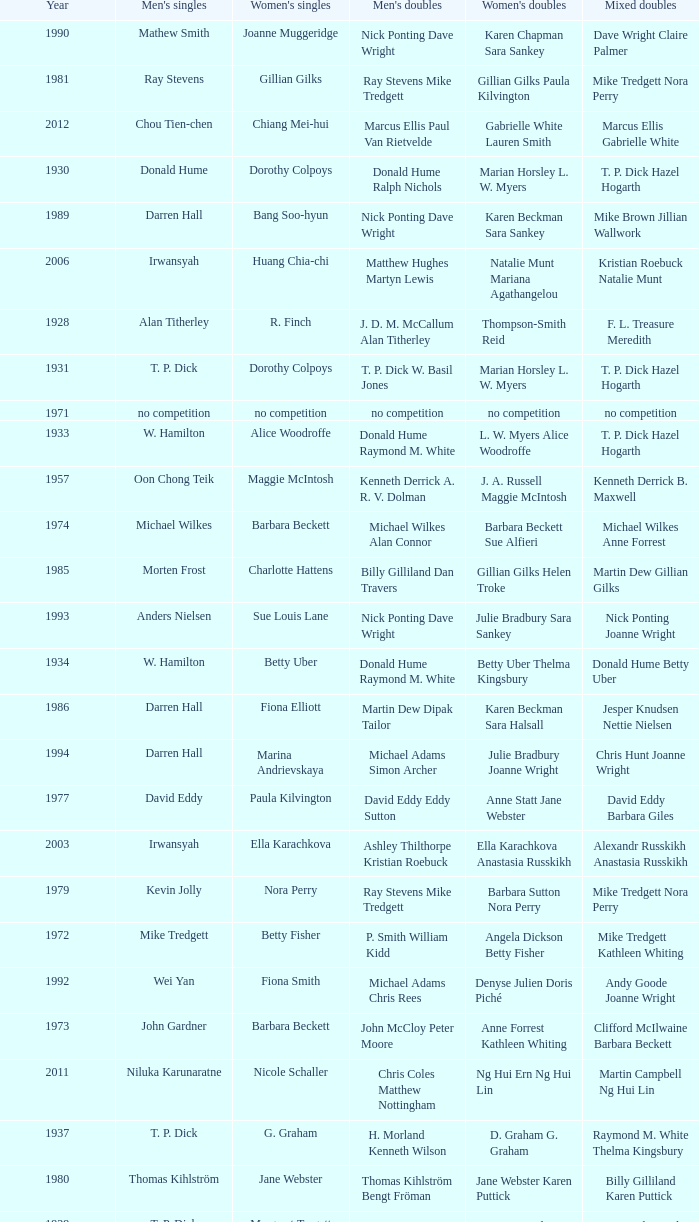Who won the Women's doubles in the year that David Eddy Eddy Sutton won the Men's doubles, and that David Eddy won the Men's singles? Anne Statt Jane Webster. 